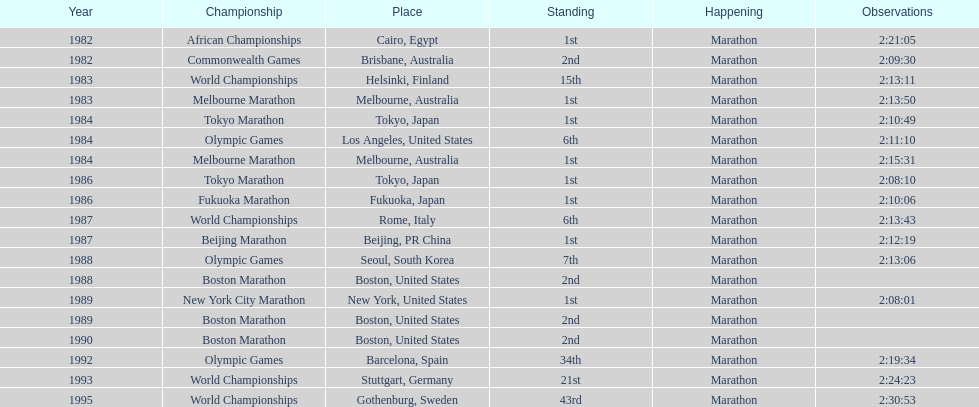What were the number of times the venue was located in the united states? 5. 